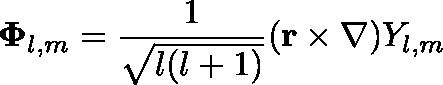<formula> <loc_0><loc_0><loc_500><loc_500>\Phi _ { l , m } = { \frac { 1 } { \sqrt { l ( l + 1 ) } } } ( r \times \nabla ) Y _ { l , m }</formula> 